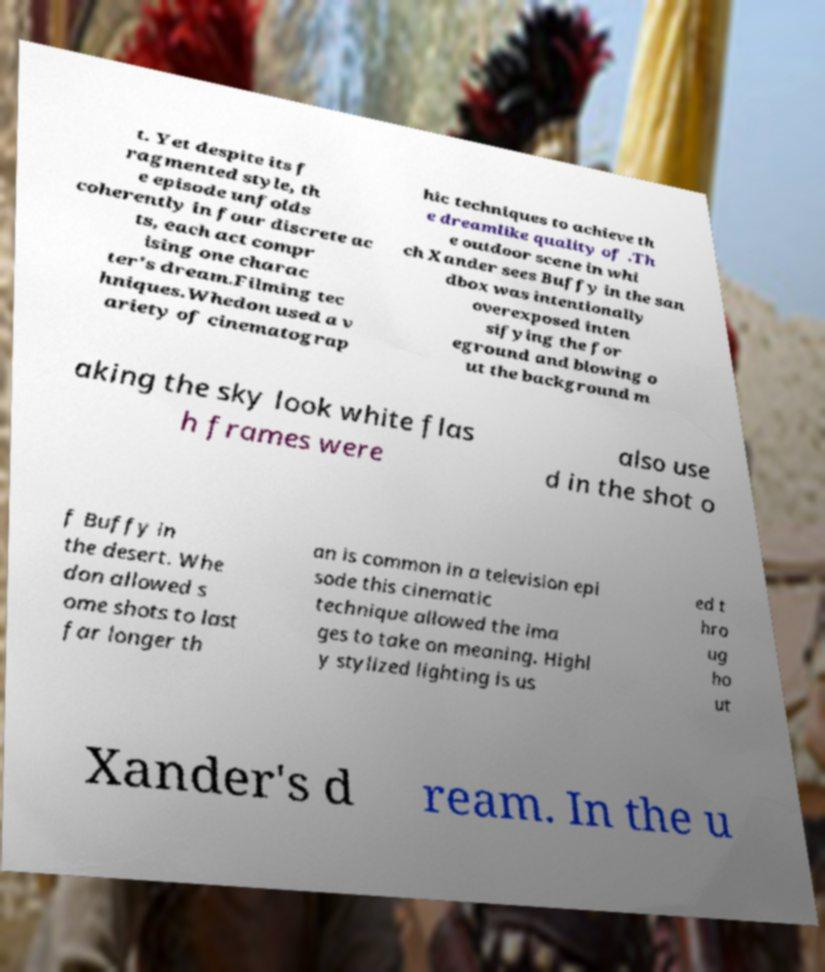Can you read and provide the text displayed in the image?This photo seems to have some interesting text. Can you extract and type it out for me? t. Yet despite its f ragmented style, th e episode unfolds coherently in four discrete ac ts, each act compr ising one charac ter's dream.Filming tec hniques.Whedon used a v ariety of cinematograp hic techniques to achieve th e dreamlike quality of .Th e outdoor scene in whi ch Xander sees Buffy in the san dbox was intentionally overexposed inten sifying the for eground and blowing o ut the background m aking the sky look white flas h frames were also use d in the shot o f Buffy in the desert. Whe don allowed s ome shots to last far longer th an is common in a television epi sode this cinematic technique allowed the ima ges to take on meaning. Highl y stylized lighting is us ed t hro ug ho ut Xander's d ream. In the u 